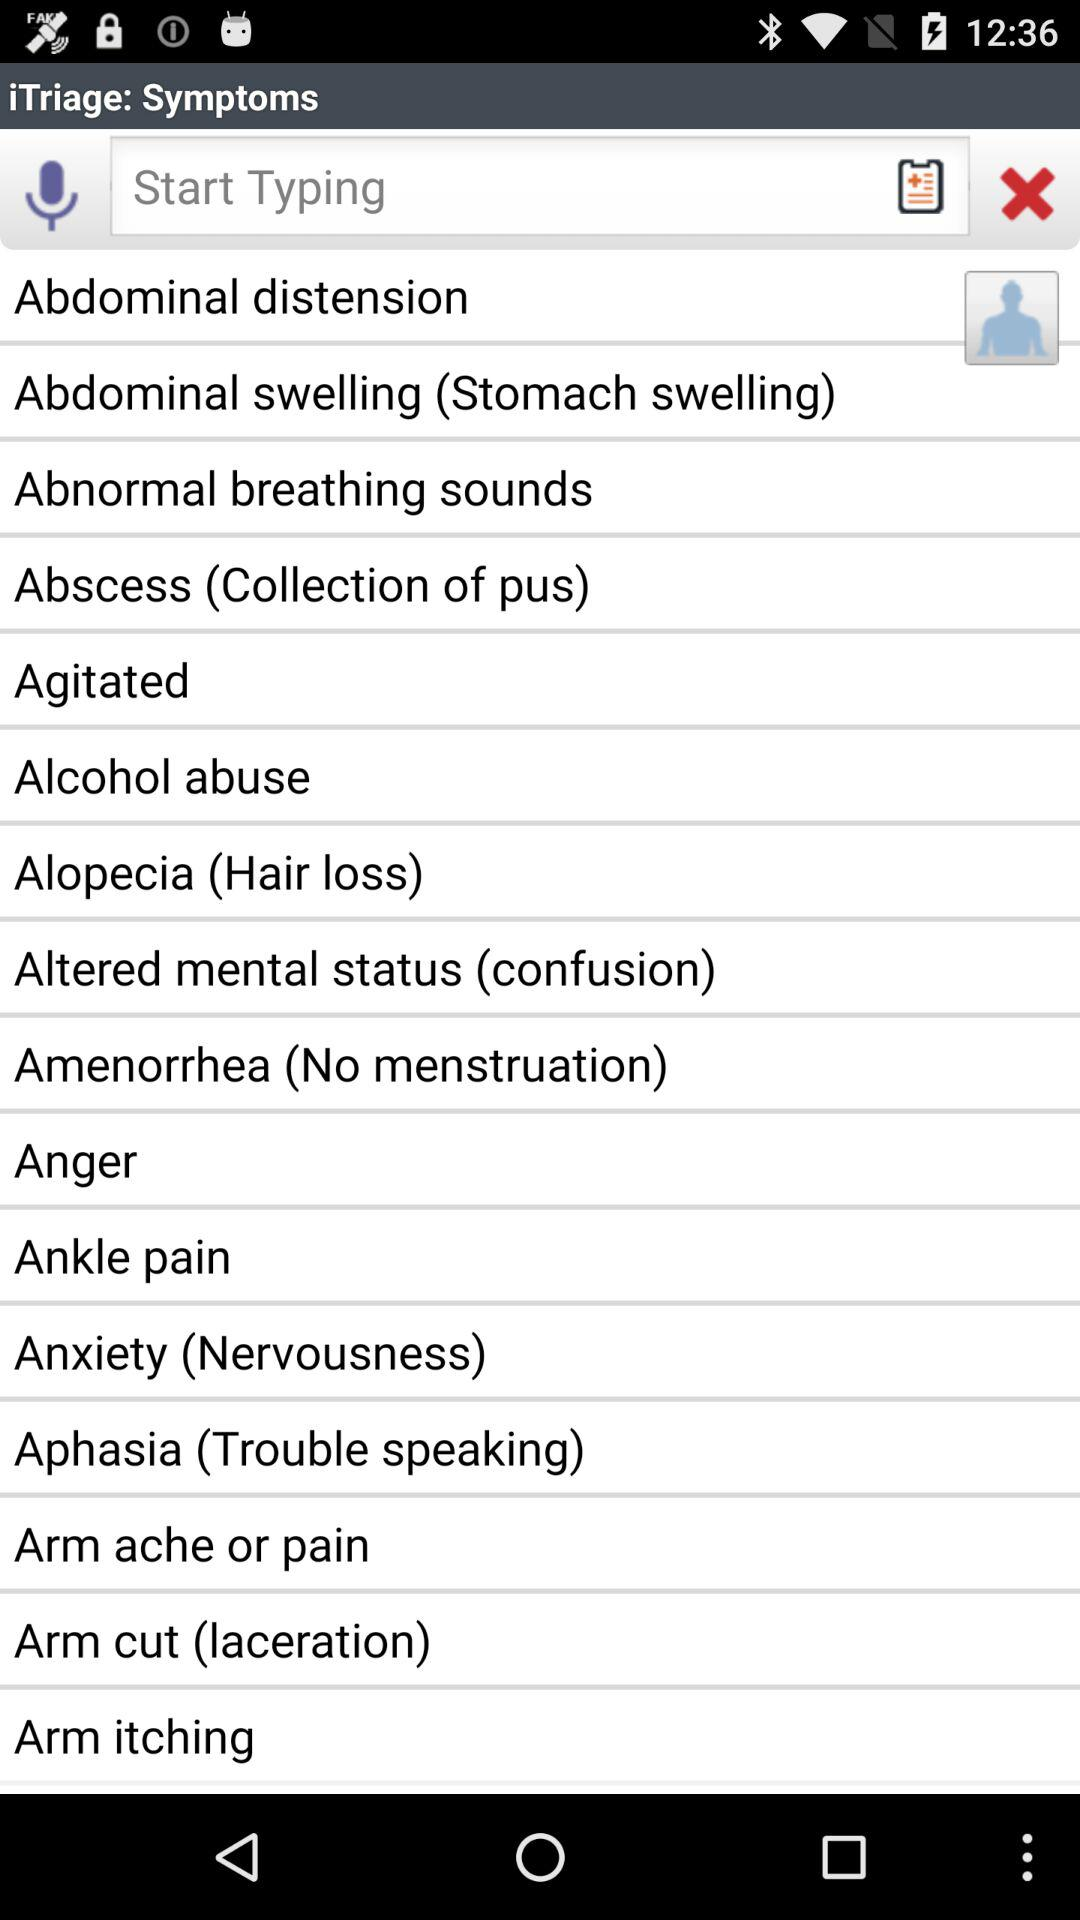What is alopecia? It is hair loss. 